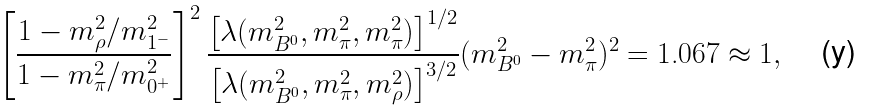<formula> <loc_0><loc_0><loc_500><loc_500>\left [ \frac { 1 - m _ { \rho } ^ { 2 } / m _ { 1 ^ { - } } ^ { 2 } } { 1 - m _ { \pi } ^ { 2 } / m _ { 0 ^ { + } } ^ { 2 } } \right ] ^ { 2 } \frac { \left [ \lambda ( m _ { B ^ { 0 } } ^ { 2 } , m _ { \pi } ^ { 2 } , m _ { \pi } ^ { 2 } ) \right ] ^ { 1 / 2 } } { \left [ \lambda ( m _ { B ^ { 0 } } ^ { 2 } , m _ { \pi } ^ { 2 } , m _ { \rho } ^ { 2 } ) \right ] ^ { 3 / 2 } } ( m _ { B ^ { 0 } } ^ { 2 } - m _ { \pi } ^ { 2 } ) ^ { 2 } = \text {1.067} \approx 1 ,</formula> 